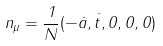<formula> <loc_0><loc_0><loc_500><loc_500>n _ { \mu } = \frac { 1 } { N } ( - \dot { a } , \dot { t } , 0 , 0 , 0 )</formula> 